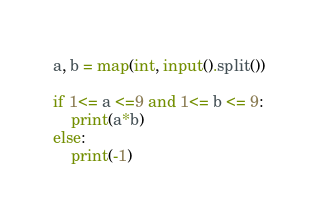Convert code to text. <code><loc_0><loc_0><loc_500><loc_500><_Python_>a, b = map(int, input().split())

if 1<= a <=9 and 1<= b <= 9:
    print(a*b)
else:
    print(-1)</code> 